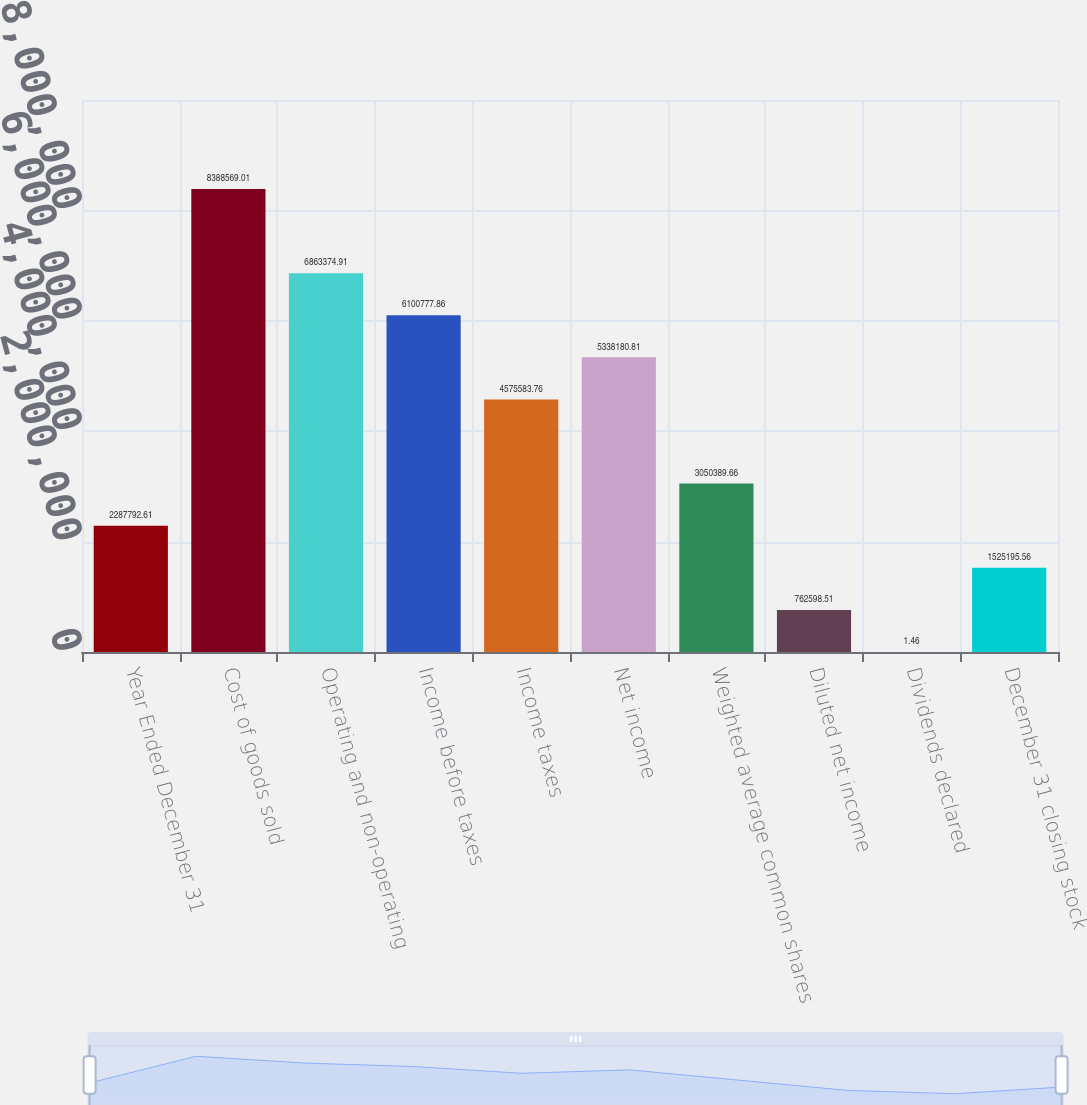Convert chart. <chart><loc_0><loc_0><loc_500><loc_500><bar_chart><fcel>Year Ended December 31<fcel>Cost of goods sold<fcel>Operating and non-operating<fcel>Income before taxes<fcel>Income taxes<fcel>Net income<fcel>Weighted average common shares<fcel>Diluted net income<fcel>Dividends declared<fcel>December 31 closing stock<nl><fcel>2.28779e+06<fcel>8.38857e+06<fcel>6.86337e+06<fcel>6.10078e+06<fcel>4.57558e+06<fcel>5.33818e+06<fcel>3.05039e+06<fcel>762599<fcel>1.46<fcel>1.5252e+06<nl></chart> 